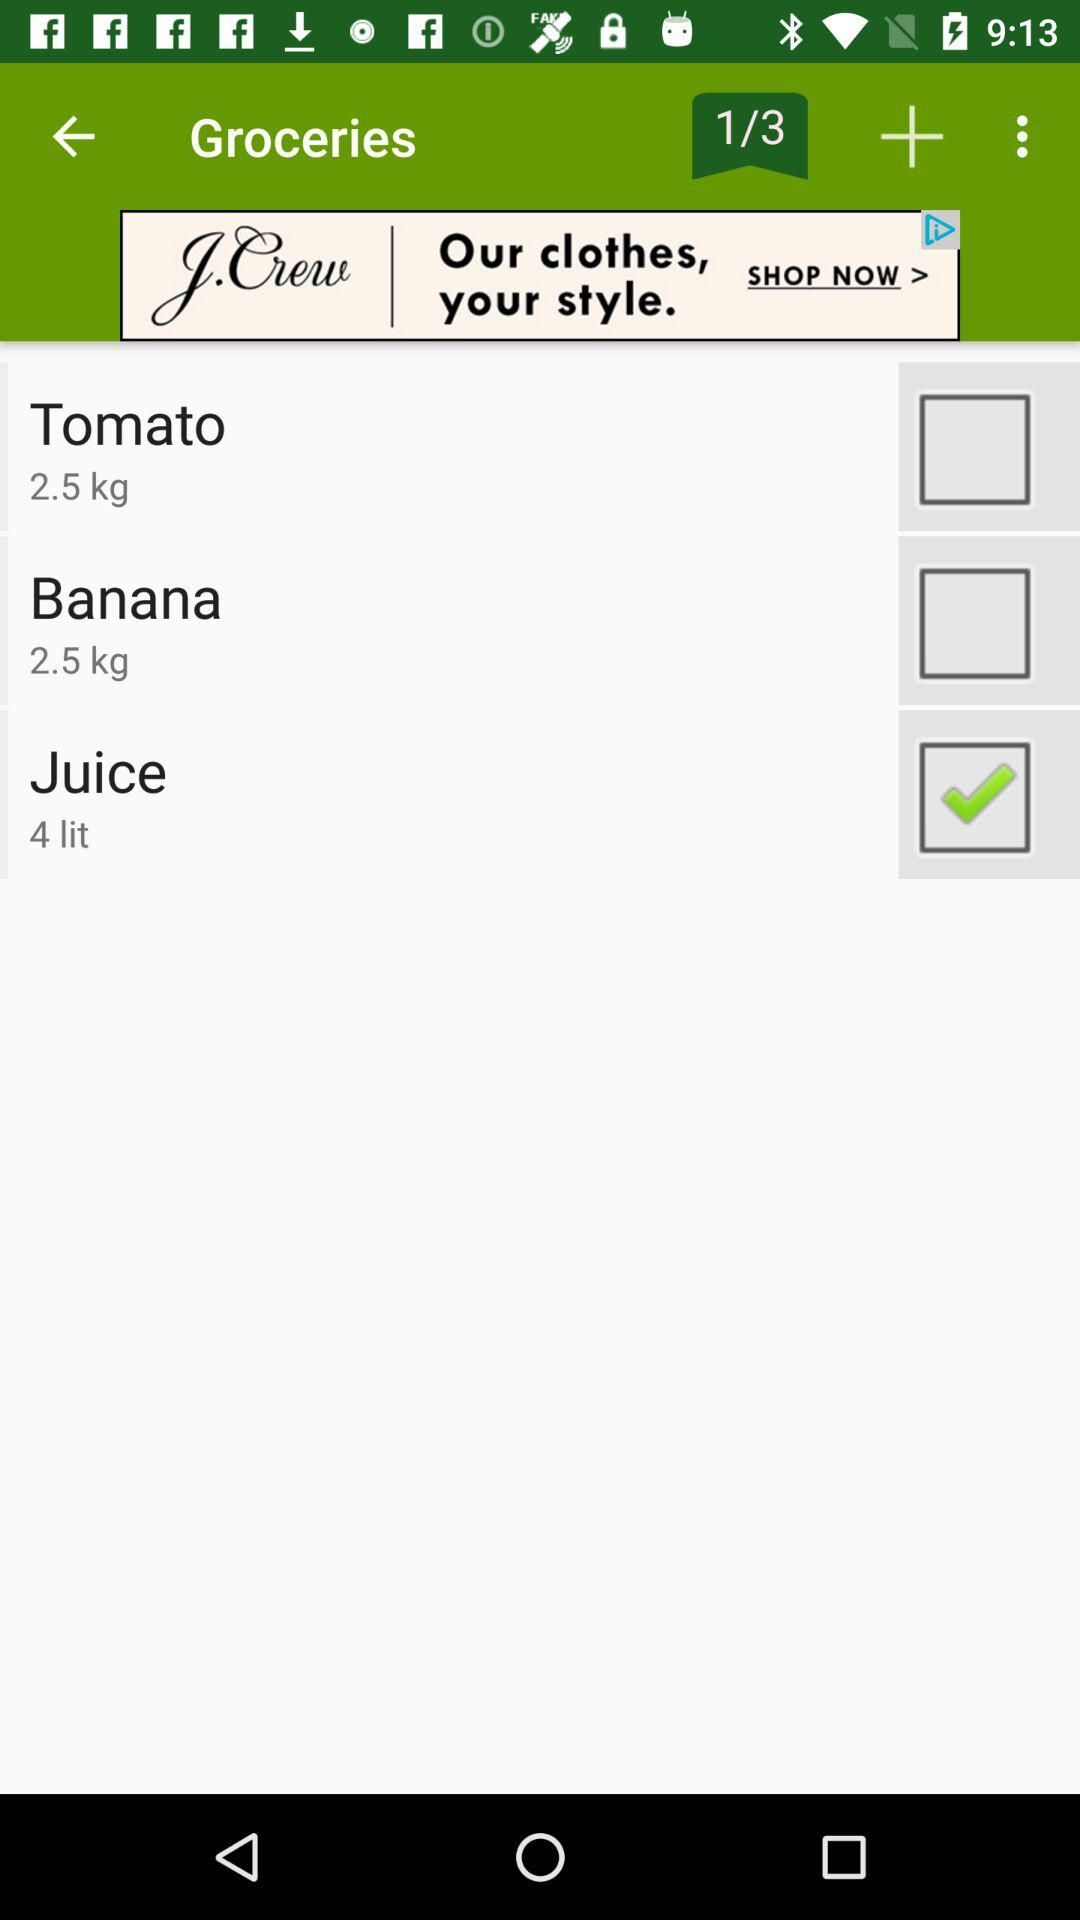Which option is checked? The checked option is "Juice". 